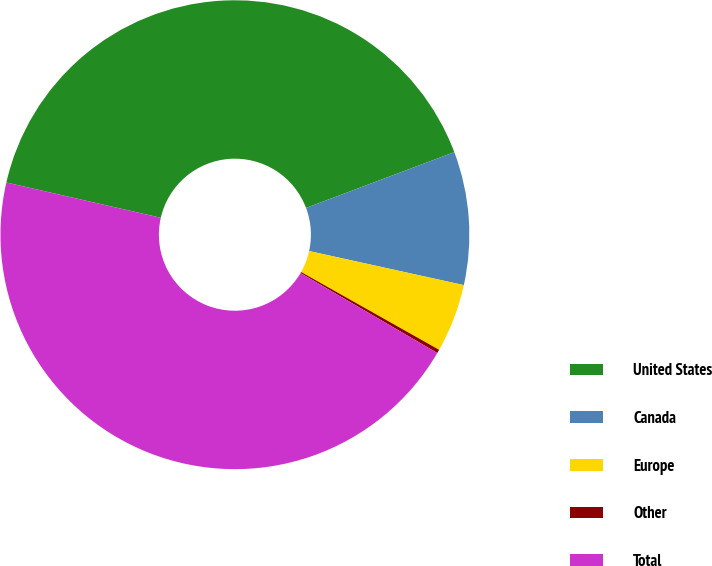Convert chart to OTSL. <chart><loc_0><loc_0><loc_500><loc_500><pie_chart><fcel>United States<fcel>Canada<fcel>Europe<fcel>Other<fcel>Total<nl><fcel>40.7%<fcel>9.18%<fcel>4.72%<fcel>0.25%<fcel>45.16%<nl></chart> 